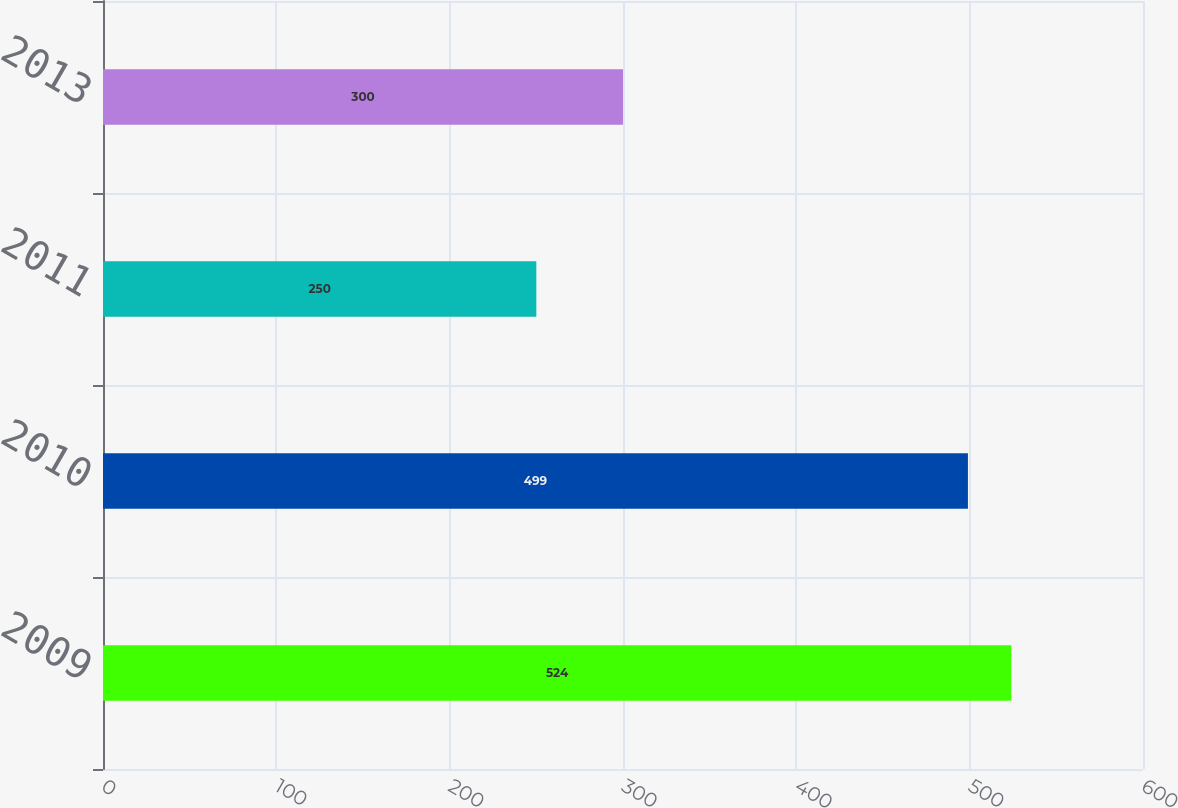Convert chart to OTSL. <chart><loc_0><loc_0><loc_500><loc_500><bar_chart><fcel>2009<fcel>2010<fcel>2011<fcel>2013<nl><fcel>524<fcel>499<fcel>250<fcel>300<nl></chart> 